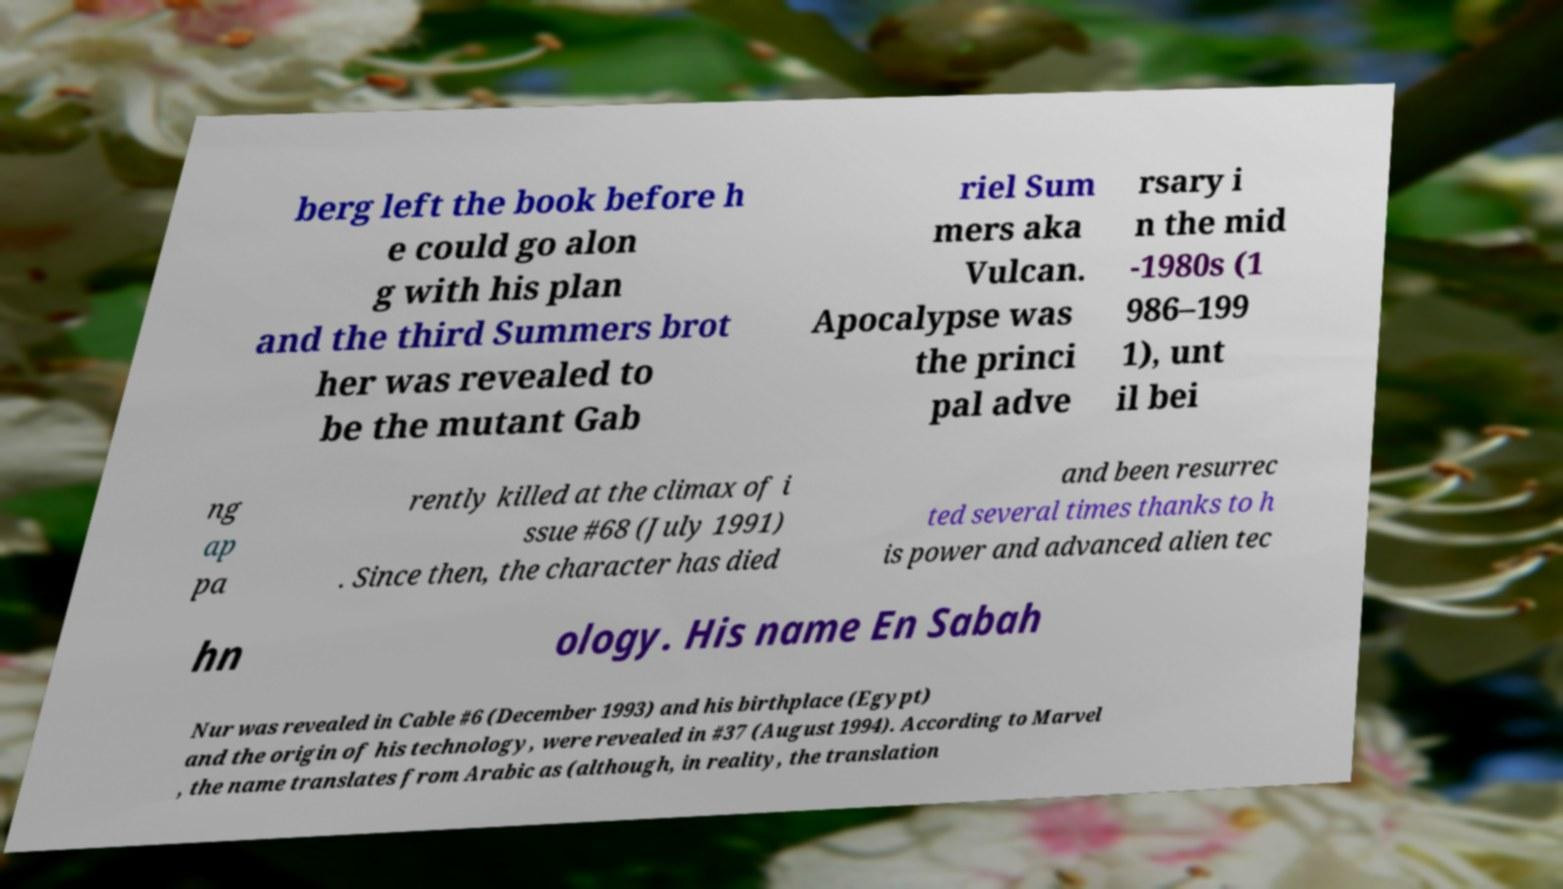Can you accurately transcribe the text from the provided image for me? berg left the book before h e could go alon g with his plan and the third Summers brot her was revealed to be the mutant Gab riel Sum mers aka Vulcan. Apocalypse was the princi pal adve rsary i n the mid -1980s (1 986–199 1), unt il bei ng ap pa rently killed at the climax of i ssue #68 (July 1991) . Since then, the character has died and been resurrec ted several times thanks to h is power and advanced alien tec hn ology. His name En Sabah Nur was revealed in Cable #6 (December 1993) and his birthplace (Egypt) and the origin of his technology, were revealed in #37 (August 1994). According to Marvel , the name translates from Arabic as (although, in reality, the translation 